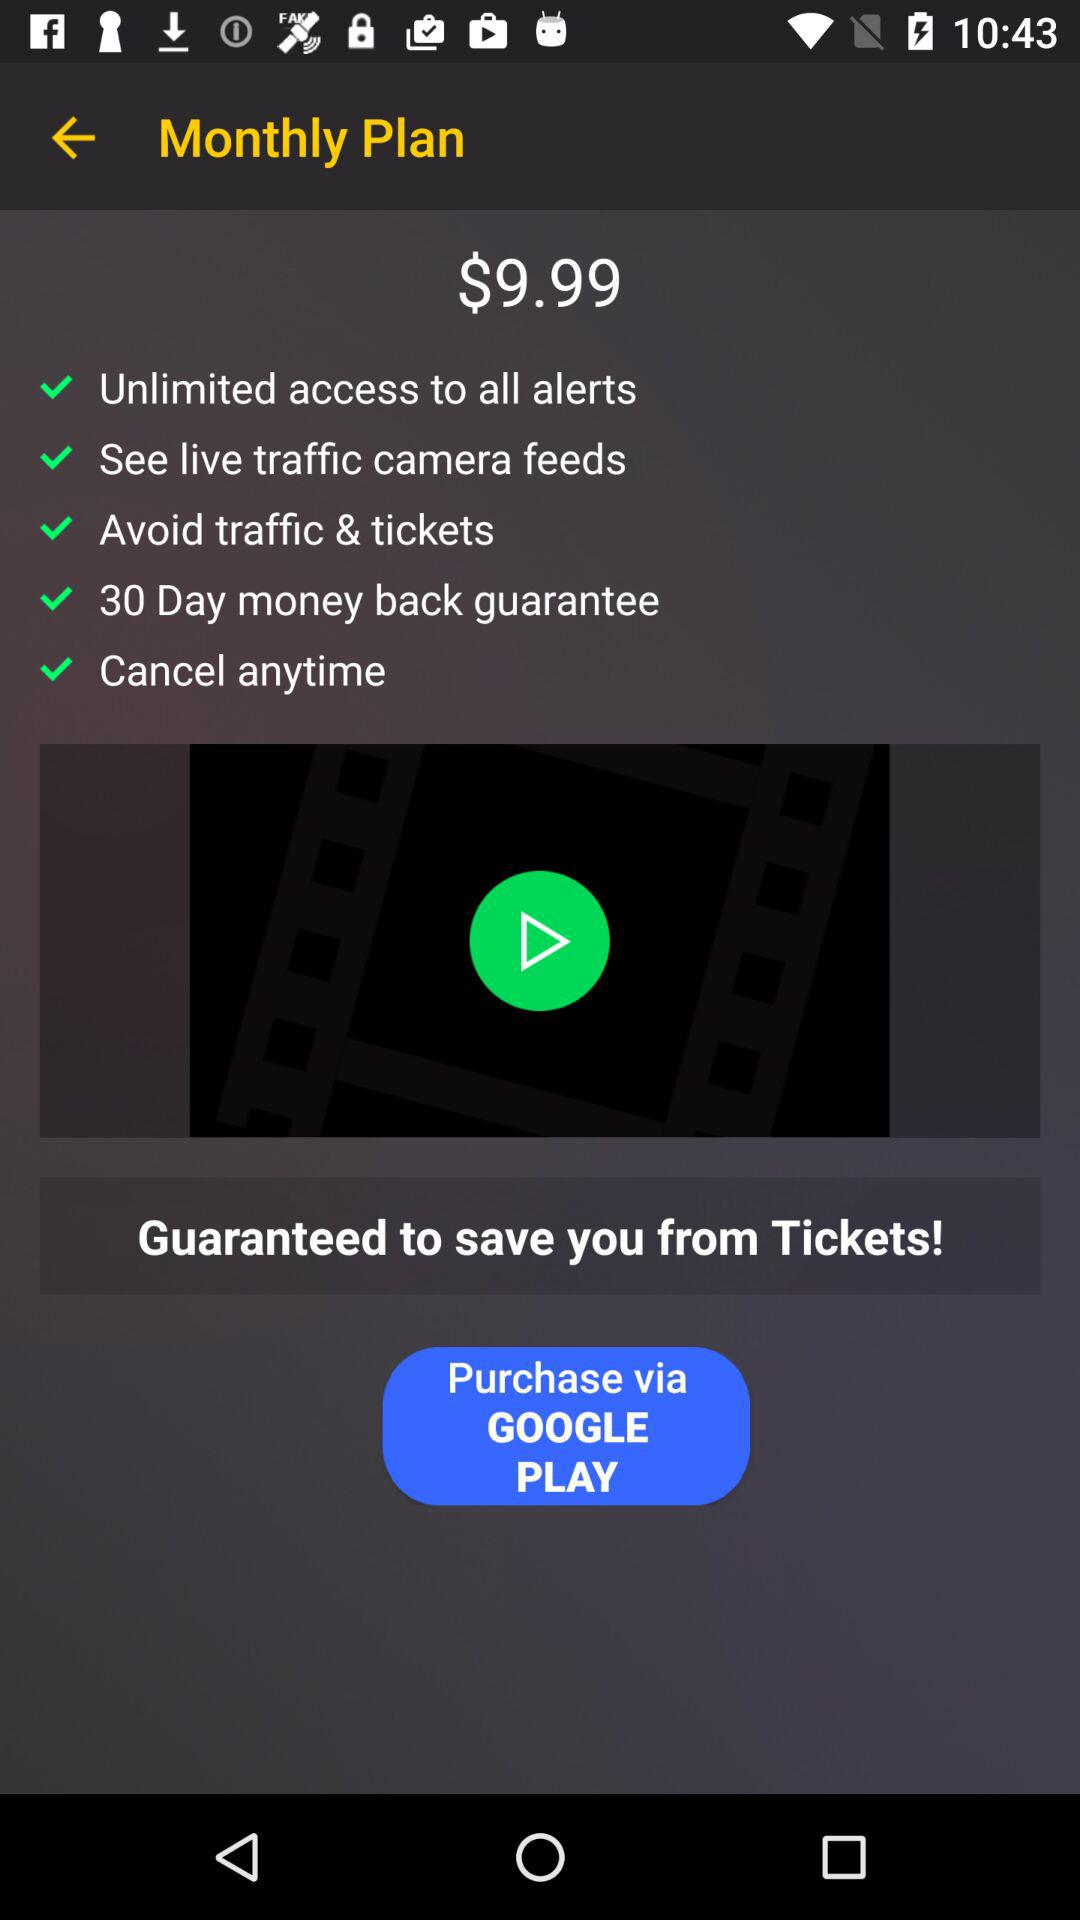How many features are included in the monthly plan?
Answer the question using a single word or phrase. 5 